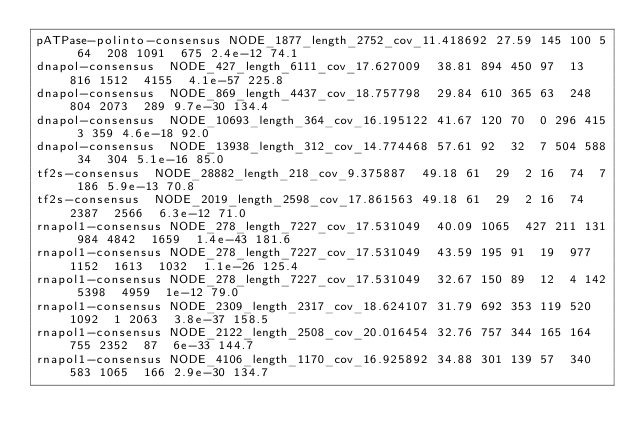Convert code to text. <code><loc_0><loc_0><loc_500><loc_500><_SQL_>pATPase-polinto-consensus	NODE_1877_length_2752_cov_11.418692	27.59	145	100	5	64	208	1091	675	2.4e-12	74.1
dnapol-consensus	NODE_427_length_6111_cov_17.627009	38.81	894	450	97	13	816	1512	4155	4.1e-57	225.8
dnapol-consensus	NODE_869_length_4437_cov_18.757798	29.84	610	365	63	248	804	2073	289	9.7e-30	134.4
dnapol-consensus	NODE_10693_length_364_cov_16.195122	41.67	120	70	0	296	415	3	359	4.6e-18	92.0
dnapol-consensus	NODE_13938_length_312_cov_14.774468	57.61	92	32	7	504	588	34	304	5.1e-16	85.0
tf2s-consensus	NODE_28882_length_218_cov_9.375887	49.18	61	29	2	16	74	7	186	5.9e-13	70.8
tf2s-consensus	NODE_2019_length_2598_cov_17.861563	49.18	61	29	2	16	74	2387	2566	6.3e-12	71.0
rnapol1-consensus	NODE_278_length_7227_cov_17.531049	40.09	1065	427	211	131	984	4842	1659	1.4e-43	181.6
rnapol1-consensus	NODE_278_length_7227_cov_17.531049	43.59	195	91	19	977	1152	1613	1032	1.1e-26	125.4
rnapol1-consensus	NODE_278_length_7227_cov_17.531049	32.67	150	89	12	4	142	5398	4959	1e-12	79.0
rnapol1-consensus	NODE_2309_length_2317_cov_18.624107	31.79	692	353	119	520	1092	1	2063	3.8e-37	158.5
rnapol1-consensus	NODE_2122_length_2508_cov_20.016454	32.76	757	344	165	164	755	2352	87	6e-33	144.7
rnapol1-consensus	NODE_4106_length_1170_cov_16.925892	34.88	301	139	57	340	583	1065	166	2.9e-30	134.7</code> 